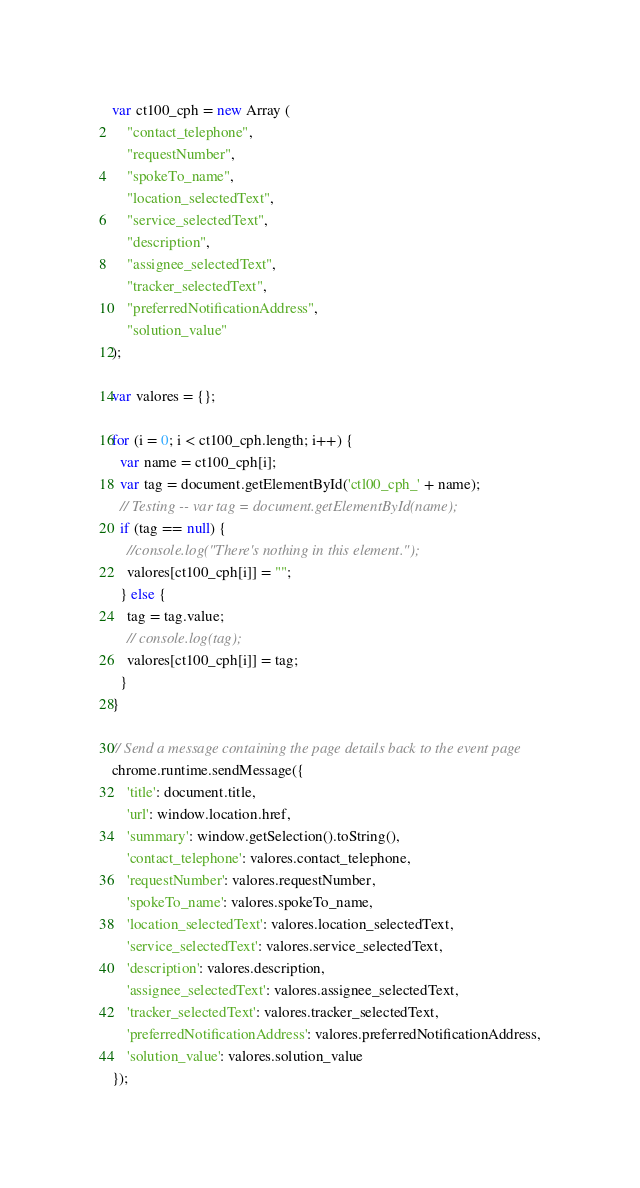Convert code to text. <code><loc_0><loc_0><loc_500><loc_500><_JavaScript_>var ct100_cph = new Array (
	"contact_telephone",
	"requestNumber",
	"spokeTo_name",
	"location_selectedText",
	"service_selectedText",
	"description",
	"assignee_selectedText",
	"tracker_selectedText",
	"preferredNotificationAddress",
	"solution_value"
);

var valores = {};

for (i = 0; i < ct100_cph.length; i++) {
  var name = ct100_cph[i];
  var tag = document.getElementById('ctl00_cph_' + name);
  // Testing -- var tag = document.getElementById(name);
  if (tag == null) {
    //console.log("There's nothing in this element.");
    valores[ct100_cph[i]] = "";
  } else {
    tag = tag.value;
    // console.log(tag);
    valores[ct100_cph[i]] = tag;
  }
}

// Send a message containing the page details back to the event page
chrome.runtime.sendMessage({
    'title': document.title,
    'url': window.location.href,
    'summary': window.getSelection().toString(),
    'contact_telephone': valores.contact_telephone,
    'requestNumber': valores.requestNumber,
    'spokeTo_name': valores.spokeTo_name,
    'location_selectedText': valores.location_selectedText,
    'service_selectedText': valores.service_selectedText,
    'description': valores.description,
    'assignee_selectedText': valores.assignee_selectedText,
    'tracker_selectedText': valores.tracker_selectedText,
    'preferredNotificationAddress': valores.preferredNotificationAddress,
    'solution_value': valores.solution_value
});
</code> 